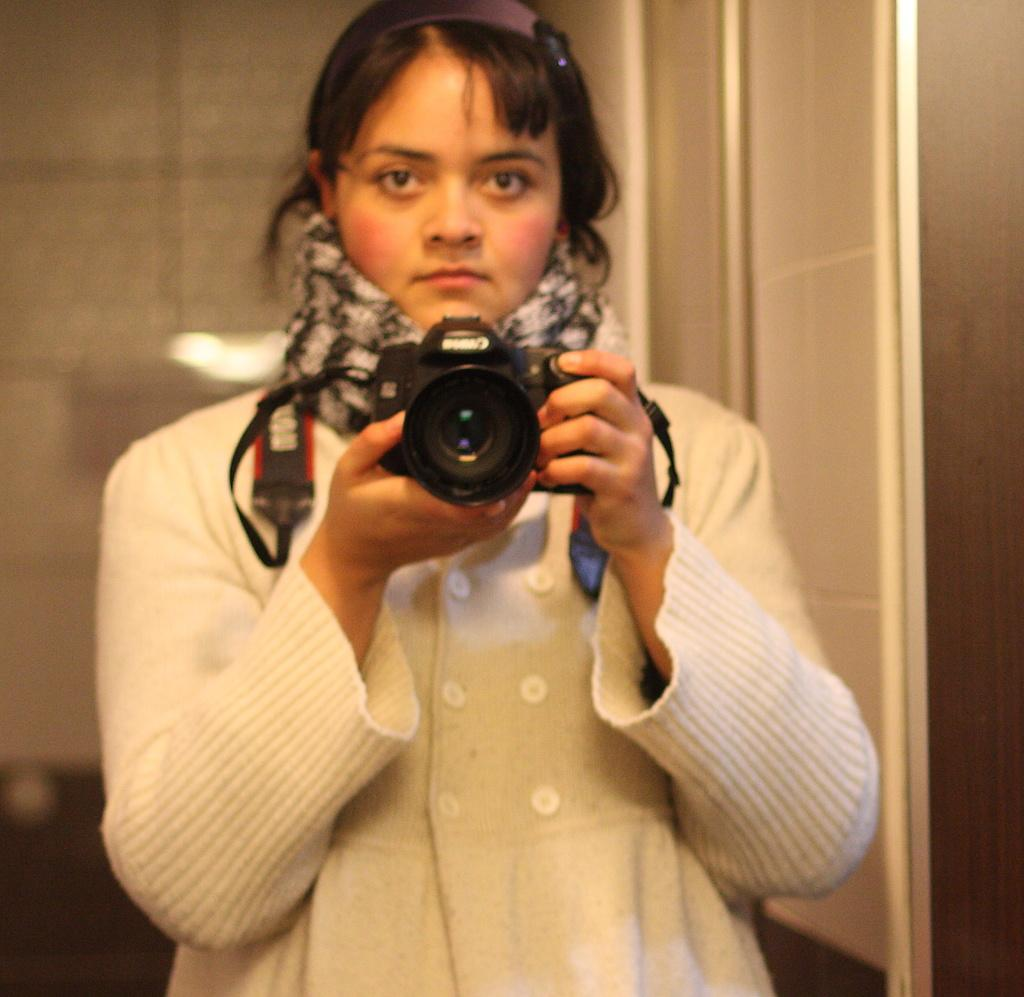Who is the main subject in the image? There is a lady in the image. What is the lady wearing? The lady is wearing a white jacket. What is the lady holding in the image? The lady is holding a camera. What is the lady doing with the camera? The lady is taking a picture in a mirror. What type of line can be seen in the image? There is no line present in the image. What season is depicted in the image? The image does not depict a specific season, as there are no seasonal cues provided. 